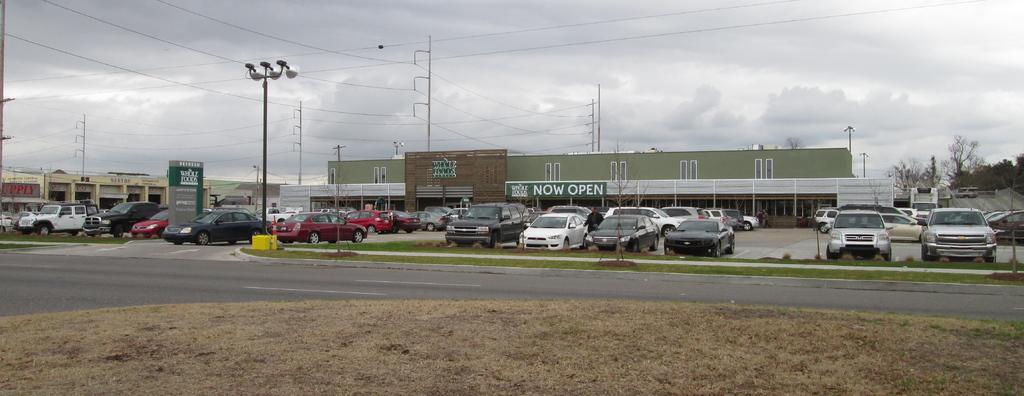<image>
Describe the image concisely. A Whole Foods parking lot has several cars parked in it. 